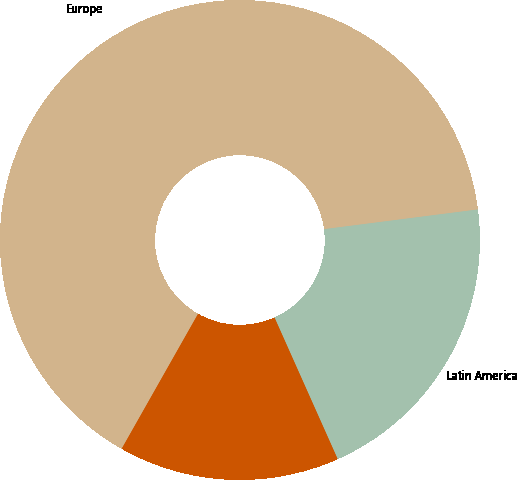Convert chart to OTSL. <chart><loc_0><loc_0><loc_500><loc_500><pie_chart><fcel>Europe<fcel>Latin America<fcel>Asia Pacific<nl><fcel>64.77%<fcel>20.35%<fcel>14.88%<nl></chart> 